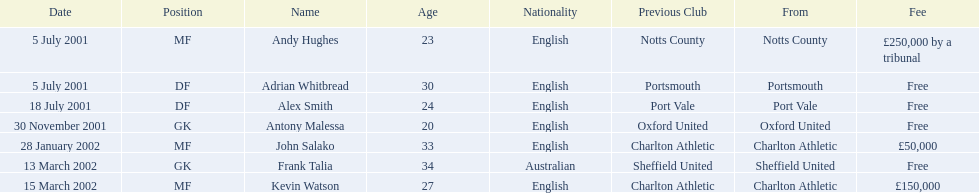Who are all the players? Andy Hughes, Adrian Whitbread, Alex Smith, Antony Malessa, John Salako, Frank Talia, Kevin Watson. What were their fees? £250,000 by a tribunal, Free, Free, Free, £50,000, Free, £150,000. And how much was kevin watson's fee? £150,000. 